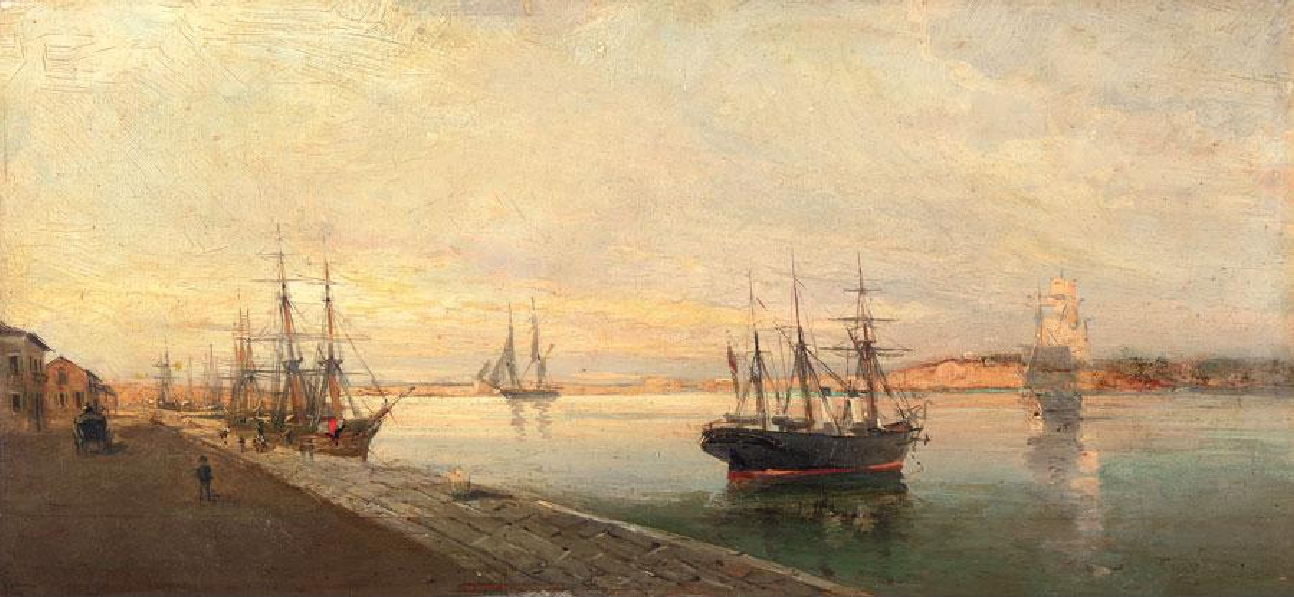Imagine you are one of the sailors on the ship. What might your day look like? As a sailor on one of these ships, your day would likely start early, just as the first light of dawn begins to illuminate the harbor. You might be tasked with preparing the ship for departure, ensuring that the cargo is secure, and checking that the sails and ropes are in good condition. Throughout the day, you could be maintaining the ship, scrubbing the decks, and making necessary repairs. Interaction with other sailors and dockworkers would be common, possibly exchanging stories or news. Your day would be physically demanding but filled with a sense of camaraderie and purpose as you work alongside your shipmates to ensure the ship's readiness for its next voyage. 